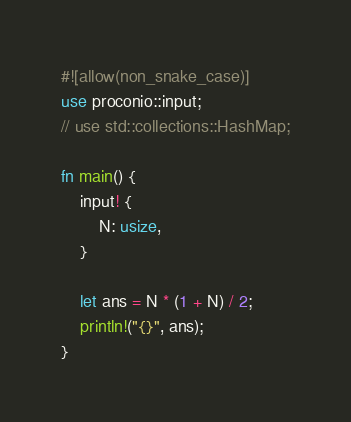<code> <loc_0><loc_0><loc_500><loc_500><_Rust_>#![allow(non_snake_case)]
use proconio::input;
// use std::collections::HashMap;

fn main() {
    input! {
        N: usize,
    }

    let ans = N * (1 + N) / 2;
    println!("{}", ans);
}
</code> 